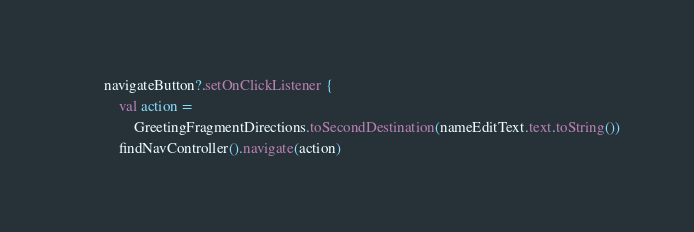Convert code to text. <code><loc_0><loc_0><loc_500><loc_500><_Kotlin_>        navigateButton?.setOnClickListener {
            val action =
                GreetingFragmentDirections.toSecondDestination(nameEditText.text.toString())
            findNavController().navigate(action)</code> 